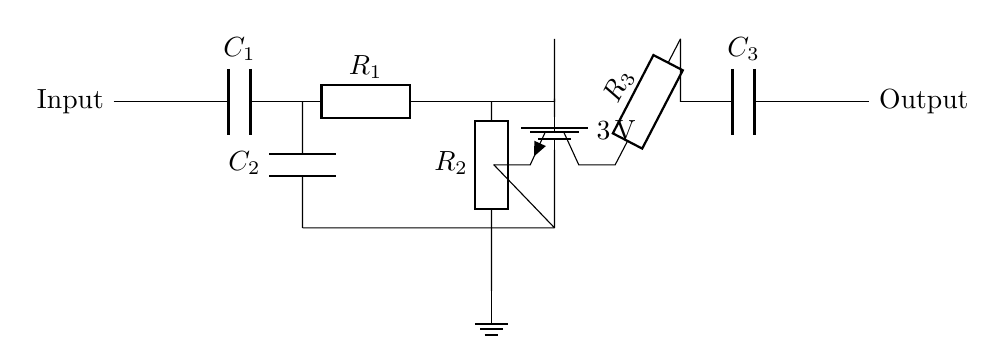What is the type of the transistor used in the circuit? The transistor indicated in the circuit is an NPN type, as seen by its symbol which features three terminals labeled for base, collector, and emitter, with the arrow pointing outward.
Answer: NPN What is the value of the input capacitor? The input capacitor is labeled C1 in the circuit diagram, but the specific value is not provided. Since the schematic focuses on the configuration, we can note that it typically blocks DC while allowing AC signals to pass.
Answer: Not specified What is the voltage of the power supply? The circuit shows a battery with a notation of three volts, indicating the voltage supplied to the amplifier circuit.
Answer: Three volts How many resistors are present in the circuit? There are three resistors in the circuit diagram, labeled as R1, R2, and R3, each serving different functions in the audio amplification process.
Answer: Three What is the function of capacitor C3 in the output stage? Capacitor C3, located in the output stage, acts as a coupling capacitor that removes any DC component from the output signal, ensuring that only the AC audio signal is delivered to the next stage.
Answer: Coupling Which component provides gain in this amplifier circuit? The NPN transistor Q1 is responsible for providing gain to the circuit, as it amplifies the input signal based on the transistor's configuration and biasing.
Answer: Transistor What is the purpose of capacitor C2 in the feedback loop? Capacitor C2, positioned in the feedback path, serves to stabilize the circuit and filter high-frequency signals, which helps prevent oscillations and improves overall sound quality.
Answer: Stabilization 